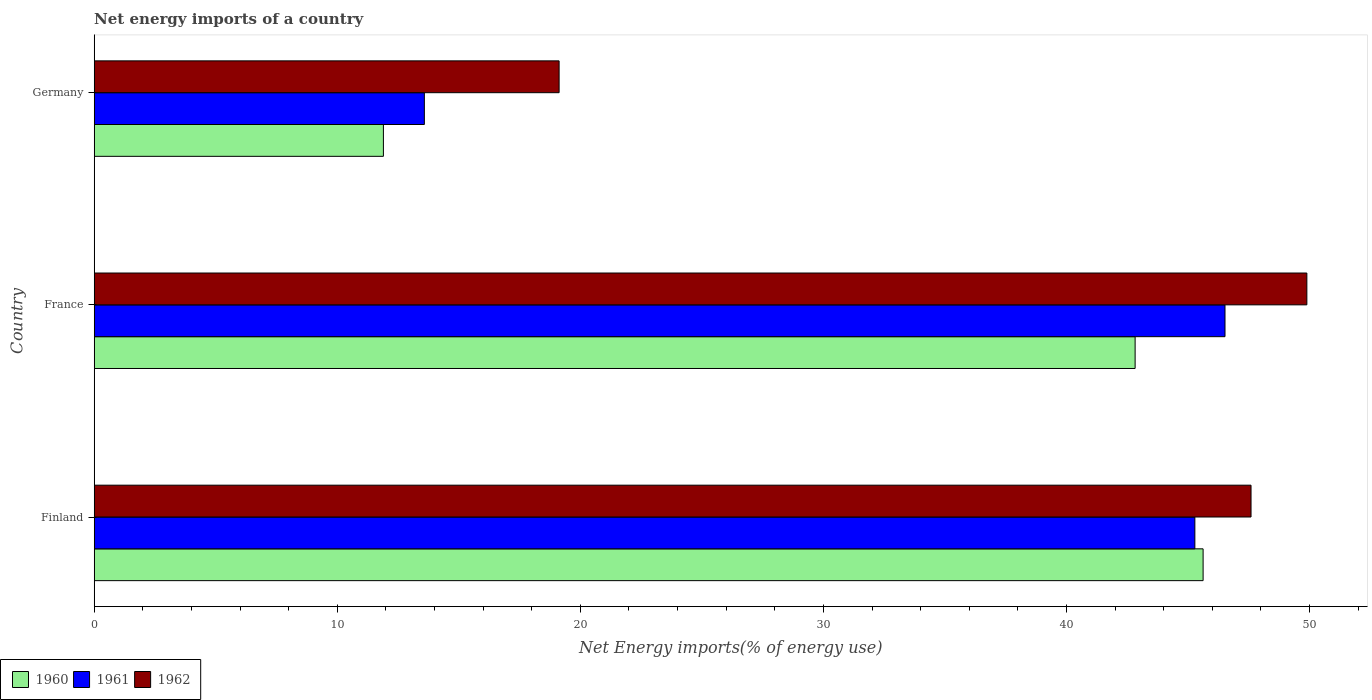How many groups of bars are there?
Offer a very short reply. 3. Are the number of bars on each tick of the Y-axis equal?
Offer a very short reply. Yes. What is the net energy imports in 1961 in France?
Keep it short and to the point. 46.52. Across all countries, what is the maximum net energy imports in 1960?
Make the answer very short. 45.62. Across all countries, what is the minimum net energy imports in 1961?
Your answer should be very brief. 13.58. In which country was the net energy imports in 1961 maximum?
Your response must be concise. France. In which country was the net energy imports in 1961 minimum?
Offer a terse response. Germany. What is the total net energy imports in 1961 in the graph?
Provide a succinct answer. 105.38. What is the difference between the net energy imports in 1960 in Finland and that in Germany?
Make the answer very short. 33.72. What is the difference between the net energy imports in 1960 in Germany and the net energy imports in 1961 in Finland?
Offer a terse response. -33.38. What is the average net energy imports in 1962 per country?
Your answer should be very brief. 38.87. What is the difference between the net energy imports in 1962 and net energy imports in 1960 in France?
Provide a short and direct response. 7.06. In how many countries, is the net energy imports in 1962 greater than 16 %?
Provide a succinct answer. 3. What is the ratio of the net energy imports in 1962 in France to that in Germany?
Keep it short and to the point. 2.61. What is the difference between the highest and the second highest net energy imports in 1961?
Make the answer very short. 1.24. What is the difference between the highest and the lowest net energy imports in 1962?
Provide a short and direct response. 30.76. In how many countries, is the net energy imports in 1962 greater than the average net energy imports in 1962 taken over all countries?
Your response must be concise. 2. Is the sum of the net energy imports in 1960 in Finland and Germany greater than the maximum net energy imports in 1962 across all countries?
Make the answer very short. Yes. What does the 2nd bar from the top in Germany represents?
Provide a succinct answer. 1961. What does the 1st bar from the bottom in Germany represents?
Make the answer very short. 1960. Are all the bars in the graph horizontal?
Offer a terse response. Yes. What is the difference between two consecutive major ticks on the X-axis?
Offer a very short reply. 10. Does the graph contain any zero values?
Your answer should be very brief. No. Does the graph contain grids?
Give a very brief answer. No. How many legend labels are there?
Provide a succinct answer. 3. How are the legend labels stacked?
Make the answer very short. Horizontal. What is the title of the graph?
Keep it short and to the point. Net energy imports of a country. Does "1971" appear as one of the legend labels in the graph?
Your answer should be very brief. No. What is the label or title of the X-axis?
Give a very brief answer. Net Energy imports(% of energy use). What is the Net Energy imports(% of energy use) in 1960 in Finland?
Provide a succinct answer. 45.62. What is the Net Energy imports(% of energy use) of 1961 in Finland?
Ensure brevity in your answer.  45.28. What is the Net Energy imports(% of energy use) in 1962 in Finland?
Your answer should be very brief. 47.59. What is the Net Energy imports(% of energy use) of 1960 in France?
Keep it short and to the point. 42.82. What is the Net Energy imports(% of energy use) in 1961 in France?
Your answer should be very brief. 46.52. What is the Net Energy imports(% of energy use) in 1962 in France?
Offer a terse response. 49.89. What is the Net Energy imports(% of energy use) of 1960 in Germany?
Your answer should be compact. 11.9. What is the Net Energy imports(% of energy use) in 1961 in Germany?
Make the answer very short. 13.58. What is the Net Energy imports(% of energy use) of 1962 in Germany?
Your answer should be very brief. 19.13. Across all countries, what is the maximum Net Energy imports(% of energy use) in 1960?
Ensure brevity in your answer.  45.62. Across all countries, what is the maximum Net Energy imports(% of energy use) in 1961?
Provide a short and direct response. 46.52. Across all countries, what is the maximum Net Energy imports(% of energy use) of 1962?
Provide a short and direct response. 49.89. Across all countries, what is the minimum Net Energy imports(% of energy use) of 1960?
Your response must be concise. 11.9. Across all countries, what is the minimum Net Energy imports(% of energy use) of 1961?
Provide a succinct answer. 13.58. Across all countries, what is the minimum Net Energy imports(% of energy use) of 1962?
Make the answer very short. 19.13. What is the total Net Energy imports(% of energy use) of 1960 in the graph?
Keep it short and to the point. 100.34. What is the total Net Energy imports(% of energy use) in 1961 in the graph?
Your answer should be compact. 105.38. What is the total Net Energy imports(% of energy use) in 1962 in the graph?
Keep it short and to the point. 116.61. What is the difference between the Net Energy imports(% of energy use) of 1960 in Finland and that in France?
Make the answer very short. 2.8. What is the difference between the Net Energy imports(% of energy use) in 1961 in Finland and that in France?
Make the answer very short. -1.24. What is the difference between the Net Energy imports(% of energy use) in 1962 in Finland and that in France?
Your answer should be very brief. -2.3. What is the difference between the Net Energy imports(% of energy use) in 1960 in Finland and that in Germany?
Make the answer very short. 33.72. What is the difference between the Net Energy imports(% of energy use) of 1961 in Finland and that in Germany?
Your answer should be very brief. 31.7. What is the difference between the Net Energy imports(% of energy use) in 1962 in Finland and that in Germany?
Provide a short and direct response. 28.47. What is the difference between the Net Energy imports(% of energy use) of 1960 in France and that in Germany?
Your answer should be very brief. 30.93. What is the difference between the Net Energy imports(% of energy use) in 1961 in France and that in Germany?
Make the answer very short. 32.94. What is the difference between the Net Energy imports(% of energy use) of 1962 in France and that in Germany?
Make the answer very short. 30.76. What is the difference between the Net Energy imports(% of energy use) in 1960 in Finland and the Net Energy imports(% of energy use) in 1961 in France?
Offer a very short reply. -0.9. What is the difference between the Net Energy imports(% of energy use) of 1960 in Finland and the Net Energy imports(% of energy use) of 1962 in France?
Offer a very short reply. -4.27. What is the difference between the Net Energy imports(% of energy use) in 1961 in Finland and the Net Energy imports(% of energy use) in 1962 in France?
Offer a very short reply. -4.61. What is the difference between the Net Energy imports(% of energy use) of 1960 in Finland and the Net Energy imports(% of energy use) of 1961 in Germany?
Give a very brief answer. 32.04. What is the difference between the Net Energy imports(% of energy use) of 1960 in Finland and the Net Energy imports(% of energy use) of 1962 in Germany?
Your answer should be compact. 26.49. What is the difference between the Net Energy imports(% of energy use) in 1961 in Finland and the Net Energy imports(% of energy use) in 1962 in Germany?
Make the answer very short. 26.15. What is the difference between the Net Energy imports(% of energy use) in 1960 in France and the Net Energy imports(% of energy use) in 1961 in Germany?
Provide a short and direct response. 29.24. What is the difference between the Net Energy imports(% of energy use) of 1960 in France and the Net Energy imports(% of energy use) of 1962 in Germany?
Offer a terse response. 23.7. What is the difference between the Net Energy imports(% of energy use) of 1961 in France and the Net Energy imports(% of energy use) of 1962 in Germany?
Offer a terse response. 27.39. What is the average Net Energy imports(% of energy use) in 1960 per country?
Make the answer very short. 33.45. What is the average Net Energy imports(% of energy use) of 1961 per country?
Offer a terse response. 35.13. What is the average Net Energy imports(% of energy use) in 1962 per country?
Provide a succinct answer. 38.87. What is the difference between the Net Energy imports(% of energy use) in 1960 and Net Energy imports(% of energy use) in 1961 in Finland?
Provide a succinct answer. 0.34. What is the difference between the Net Energy imports(% of energy use) in 1960 and Net Energy imports(% of energy use) in 1962 in Finland?
Make the answer very short. -1.97. What is the difference between the Net Energy imports(% of energy use) in 1961 and Net Energy imports(% of energy use) in 1962 in Finland?
Ensure brevity in your answer.  -2.31. What is the difference between the Net Energy imports(% of energy use) in 1960 and Net Energy imports(% of energy use) in 1961 in France?
Your answer should be very brief. -3.7. What is the difference between the Net Energy imports(% of energy use) of 1960 and Net Energy imports(% of energy use) of 1962 in France?
Make the answer very short. -7.06. What is the difference between the Net Energy imports(% of energy use) in 1961 and Net Energy imports(% of energy use) in 1962 in France?
Give a very brief answer. -3.37. What is the difference between the Net Energy imports(% of energy use) of 1960 and Net Energy imports(% of energy use) of 1961 in Germany?
Give a very brief answer. -1.68. What is the difference between the Net Energy imports(% of energy use) in 1960 and Net Energy imports(% of energy use) in 1962 in Germany?
Provide a succinct answer. -7.23. What is the difference between the Net Energy imports(% of energy use) in 1961 and Net Energy imports(% of energy use) in 1962 in Germany?
Keep it short and to the point. -5.54. What is the ratio of the Net Energy imports(% of energy use) of 1960 in Finland to that in France?
Your answer should be very brief. 1.07. What is the ratio of the Net Energy imports(% of energy use) of 1961 in Finland to that in France?
Ensure brevity in your answer.  0.97. What is the ratio of the Net Energy imports(% of energy use) in 1962 in Finland to that in France?
Offer a very short reply. 0.95. What is the ratio of the Net Energy imports(% of energy use) in 1960 in Finland to that in Germany?
Keep it short and to the point. 3.83. What is the ratio of the Net Energy imports(% of energy use) of 1961 in Finland to that in Germany?
Keep it short and to the point. 3.33. What is the ratio of the Net Energy imports(% of energy use) in 1962 in Finland to that in Germany?
Your response must be concise. 2.49. What is the ratio of the Net Energy imports(% of energy use) in 1960 in France to that in Germany?
Offer a very short reply. 3.6. What is the ratio of the Net Energy imports(% of energy use) in 1961 in France to that in Germany?
Your answer should be very brief. 3.43. What is the ratio of the Net Energy imports(% of energy use) in 1962 in France to that in Germany?
Provide a short and direct response. 2.61. What is the difference between the highest and the second highest Net Energy imports(% of energy use) in 1960?
Offer a terse response. 2.8. What is the difference between the highest and the second highest Net Energy imports(% of energy use) in 1961?
Your answer should be very brief. 1.24. What is the difference between the highest and the second highest Net Energy imports(% of energy use) of 1962?
Ensure brevity in your answer.  2.3. What is the difference between the highest and the lowest Net Energy imports(% of energy use) of 1960?
Ensure brevity in your answer.  33.72. What is the difference between the highest and the lowest Net Energy imports(% of energy use) in 1961?
Give a very brief answer. 32.94. What is the difference between the highest and the lowest Net Energy imports(% of energy use) in 1962?
Provide a succinct answer. 30.76. 